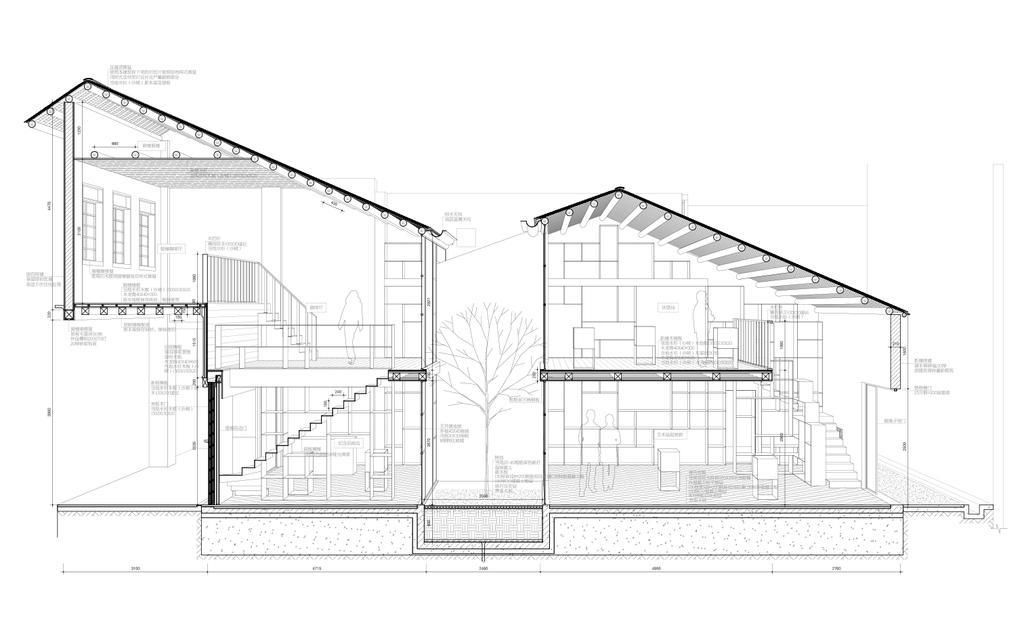Please provide a concise description of this image. This is a drawing of a house, in this image in the center there is a building and plant in the center and there is some text. 